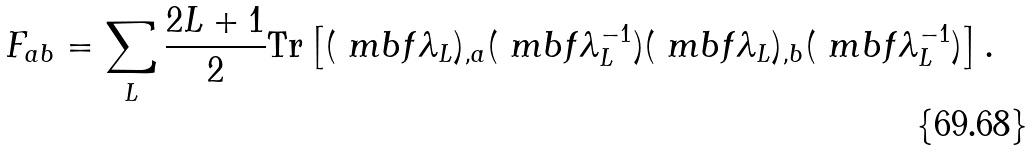Convert formula to latex. <formula><loc_0><loc_0><loc_500><loc_500>F _ { a b } = \sum _ { L } \frac { 2 L + 1 } { 2 } \text {Tr} \left [ ( \ m b f { \lambda } _ { L } ) _ { , a } ( \ m b f { \lambda } _ { L } ^ { - 1 } ) ( \ m b f { \lambda } _ { L } ) _ { , b } ( \ m b f { \lambda } _ { L } ^ { - 1 } ) \right ] .</formula> 